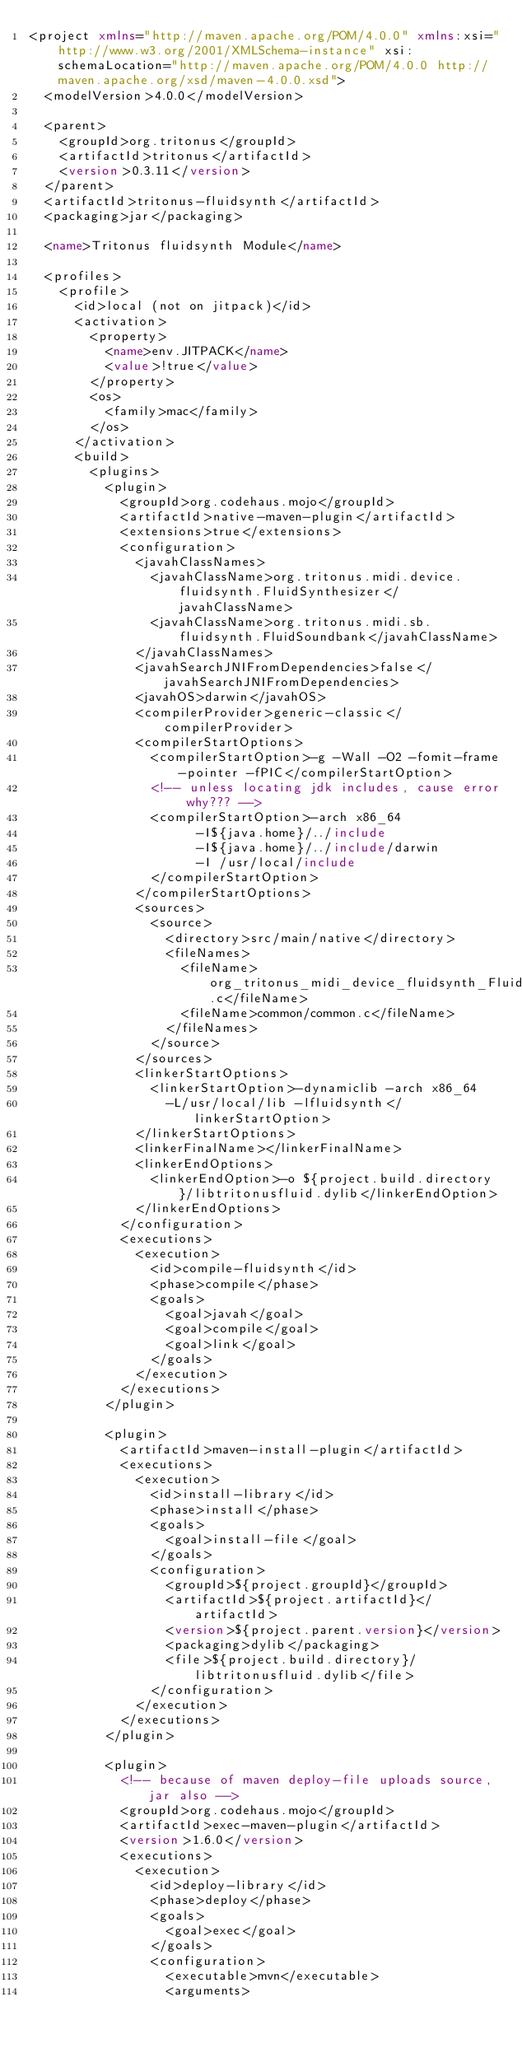<code> <loc_0><loc_0><loc_500><loc_500><_XML_><project xmlns="http://maven.apache.org/POM/4.0.0" xmlns:xsi="http://www.w3.org/2001/XMLSchema-instance" xsi:schemaLocation="http://maven.apache.org/POM/4.0.0 http://maven.apache.org/xsd/maven-4.0.0.xsd">
  <modelVersion>4.0.0</modelVersion>

  <parent>
    <groupId>org.tritonus</groupId>
    <artifactId>tritonus</artifactId>
    <version>0.3.11</version>
  </parent>
  <artifactId>tritonus-fluidsynth</artifactId>
  <packaging>jar</packaging>

  <name>Tritonus fluidsynth Module</name>

  <profiles>
    <profile>
      <id>local (not on jitpack)</id>
      <activation>
        <property>
          <name>env.JITPACK</name>
          <value>!true</value>
        </property>
        <os>
          <family>mac</family>
        </os>
      </activation>
      <build>
        <plugins>
          <plugin>
            <groupId>org.codehaus.mojo</groupId>
            <artifactId>native-maven-plugin</artifactId>
            <extensions>true</extensions>
            <configuration>
              <javahClassNames>
                <javahClassName>org.tritonus.midi.device.fluidsynth.FluidSynthesizer</javahClassName>
                <javahClassName>org.tritonus.midi.sb.fluidsynth.FluidSoundbank</javahClassName>
              </javahClassNames>
              <javahSearchJNIFromDependencies>false</javahSearchJNIFromDependencies>
              <javahOS>darwin</javahOS>
              <compilerProvider>generic-classic</compilerProvider>
              <compilerStartOptions>
                <compilerStartOption>-g -Wall -O2 -fomit-frame-pointer -fPIC</compilerStartOption>
                <!-- unless locating jdk includes, cause error why??? -->
                <compilerStartOption>-arch x86_64
                      -I${java.home}/../include
                      -I${java.home}/../include/darwin
                      -I /usr/local/include
                </compilerStartOption>
              </compilerStartOptions>
              <sources>
                <source>
                  <directory>src/main/native</directory>
                  <fileNames>
                    <fileName>org_tritonus_midi_device_fluidsynth_FluidSynthesizer.c</fileName>
                    <fileName>common/common.c</fileName>
                  </fileNames>
                </source>
              </sources>
              <linkerStartOptions>
                <linkerStartOption>-dynamiclib -arch x86_64
                  -L/usr/local/lib -lfluidsynth</linkerStartOption>
              </linkerStartOptions>
              <linkerFinalName></linkerFinalName>
              <linkerEndOptions>
                <linkerEndOption>-o ${project.build.directory}/libtritonusfluid.dylib</linkerEndOption>
              </linkerEndOptions>
            </configuration>
            <executions>
              <execution>
                <id>compile-fluidsynth</id>
                <phase>compile</phase>
                <goals>
                  <goal>javah</goal>
                  <goal>compile</goal>
                  <goal>link</goal>
                </goals>
              </execution>
            </executions>
          </plugin>

          <plugin>
            <artifactId>maven-install-plugin</artifactId>
            <executions>
              <execution>
                <id>install-library</id>
                <phase>install</phase>
                <goals>
                  <goal>install-file</goal>
                </goals>
                <configuration>
                  <groupId>${project.groupId}</groupId>
                  <artifactId>${project.artifactId}</artifactId>
                  <version>${project.parent.version}</version>
                  <packaging>dylib</packaging>
                  <file>${project.build.directory}/libtritonusfluid.dylib</file>
                </configuration>
              </execution>
            </executions>
          </plugin>

          <plugin>
            <!-- because of maven deploy-file uploads source, jar also -->
            <groupId>org.codehaus.mojo</groupId>
            <artifactId>exec-maven-plugin</artifactId>
            <version>1.6.0</version>
            <executions>
              <execution>
                <id>deploy-library</id>
                <phase>deploy</phase>
                <goals>
                  <goal>exec</goal>
                </goals>
                <configuration>
                  <executable>mvn</executable>
                  <arguments></code> 